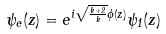<formula> <loc_0><loc_0><loc_500><loc_500>\psi _ { e } ( z ) = e ^ { i \sqrt { \frac { k + 2 } { k } } \phi ( z ) } \psi _ { 1 } ( z )</formula> 